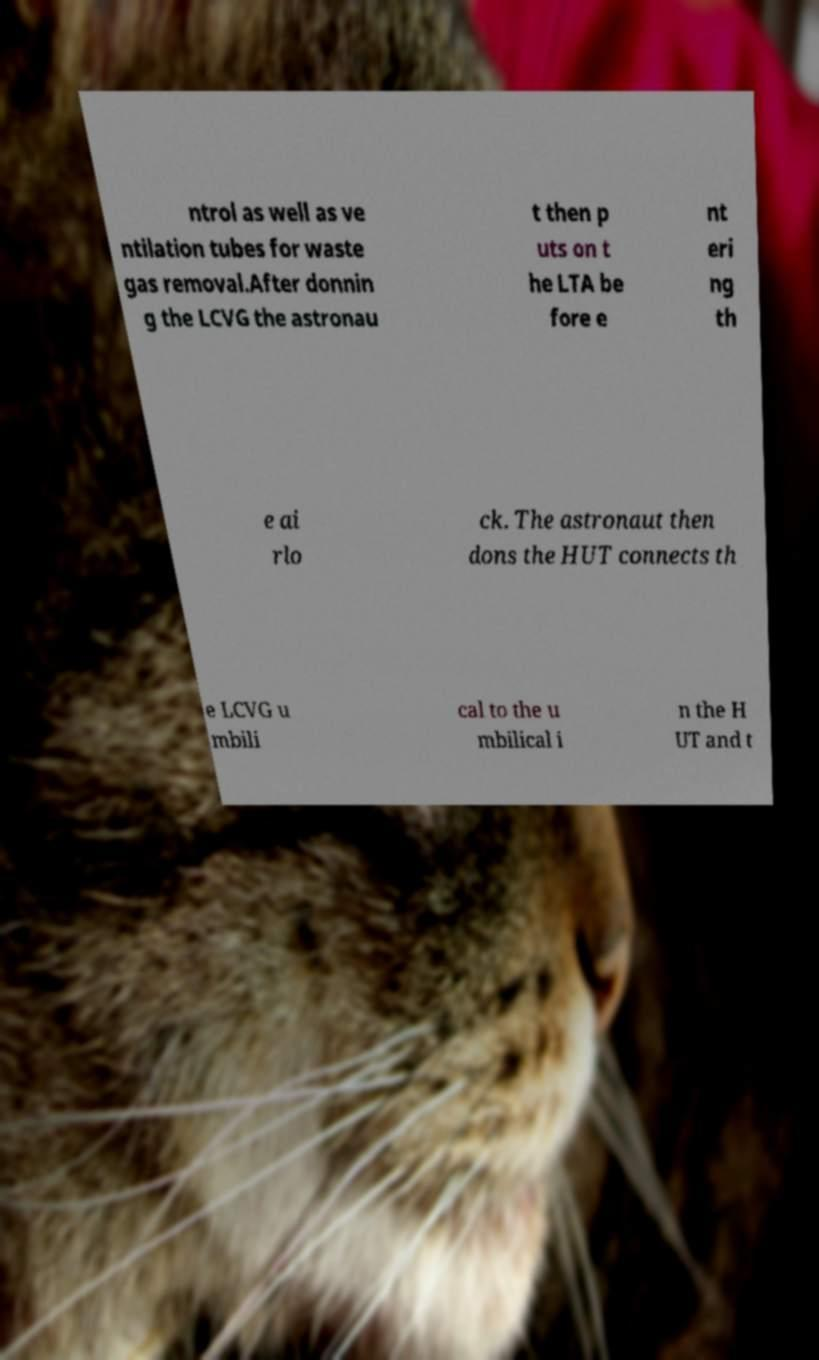I need the written content from this picture converted into text. Can you do that? ntrol as well as ve ntilation tubes for waste gas removal.After donnin g the LCVG the astronau t then p uts on t he LTA be fore e nt eri ng th e ai rlo ck. The astronaut then dons the HUT connects th e LCVG u mbili cal to the u mbilical i n the H UT and t 